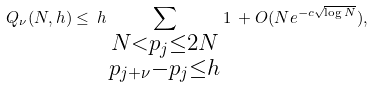Convert formula to latex. <formula><loc_0><loc_0><loc_500><loc_500>Q _ { \nu } ( N , h ) \leq \, h \sum _ { \substack { N < p _ { j } \leq 2 N \\ p _ { j + \nu } - p _ { j } \leq h } } 1 \, + O ( N e ^ { - c \sqrt { \log N } } ) ,</formula> 